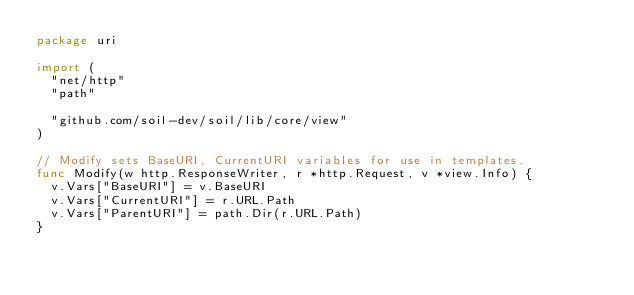Convert code to text. <code><loc_0><loc_0><loc_500><loc_500><_Go_>package uri

import (
	"net/http"
	"path"

	"github.com/soil-dev/soil/lib/core/view"
)

// Modify sets BaseURI, CurrentURI variables for use in templates.
func Modify(w http.ResponseWriter, r *http.Request, v *view.Info) {
	v.Vars["BaseURI"] = v.BaseURI
	v.Vars["CurrentURI"] = r.URL.Path
	v.Vars["ParentURI"] = path.Dir(r.URL.Path)
}
</code> 